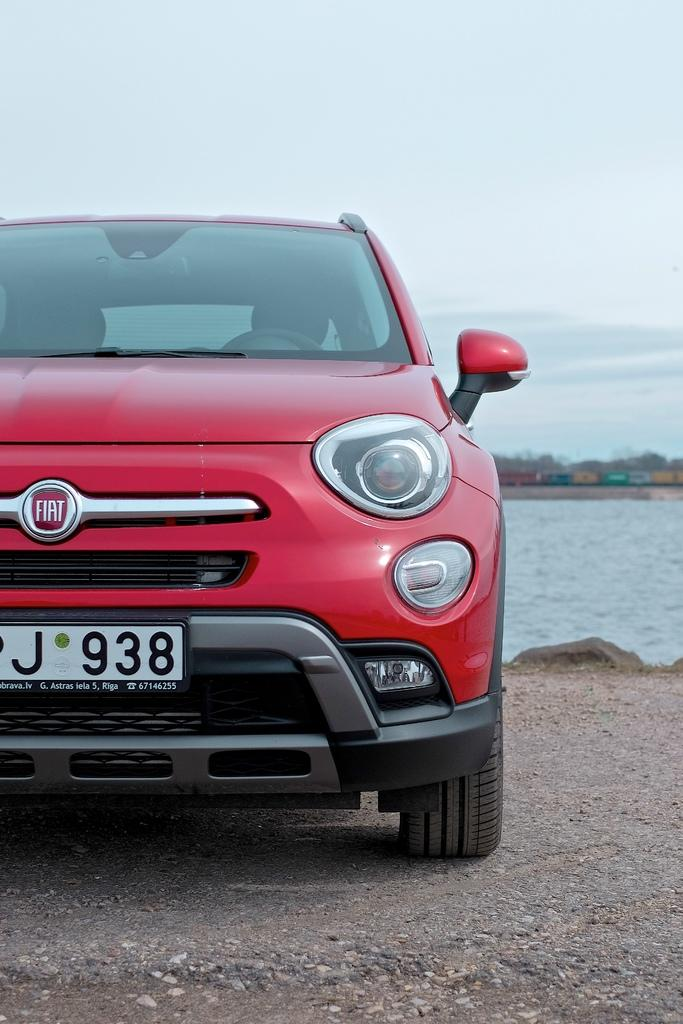What is the main subject in the foreground of the image? There is a red car in the foreground of the image. What can be seen in the image besides the red car? Water is visible in the image. What is the background of the image? The background of the image is the sky. How many birds are participating in the competition in the image? There are no birds or competition present in the image. 